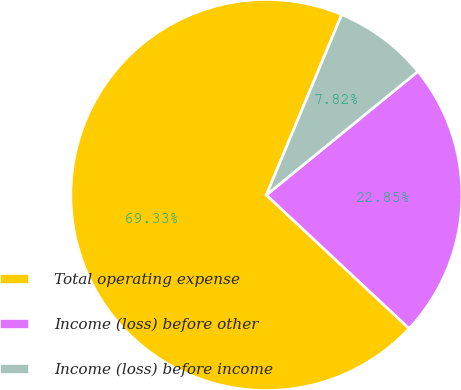Convert chart to OTSL. <chart><loc_0><loc_0><loc_500><loc_500><pie_chart><fcel>Total operating expense<fcel>Income (loss) before other<fcel>Income (loss) before income<nl><fcel>69.33%<fcel>22.85%<fcel>7.82%<nl></chart> 